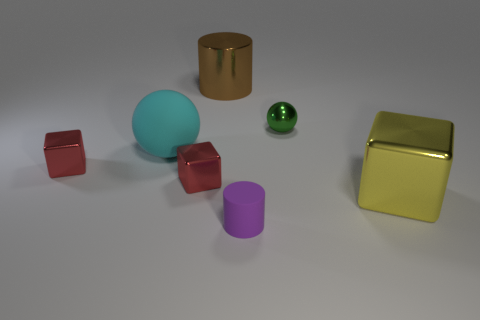Is there a big red cube that has the same material as the small purple object?
Give a very brief answer. No. The big metallic object behind the tiny thing that is to the right of the cylinder right of the big metal cylinder is what color?
Provide a short and direct response. Brown. There is a shiny block that is to the right of the big shiny cylinder; does it have the same color as the cylinder in front of the tiny green metallic sphere?
Make the answer very short. No. Is there any other thing of the same color as the big rubber thing?
Make the answer very short. No. Are there fewer purple objects to the left of the purple cylinder than green shiny balls?
Keep it short and to the point. Yes. What number of objects are there?
Offer a terse response. 7. Do the large brown shiny thing and the object in front of the big yellow shiny block have the same shape?
Provide a succinct answer. Yes. Are there fewer red objects right of the big cyan sphere than big spheres right of the large brown metallic object?
Your response must be concise. No. Are there any other things that have the same shape as the large yellow metal thing?
Make the answer very short. Yes. Do the green shiny thing and the big cyan rubber object have the same shape?
Give a very brief answer. Yes. 